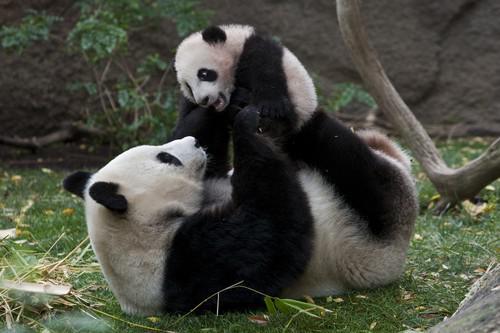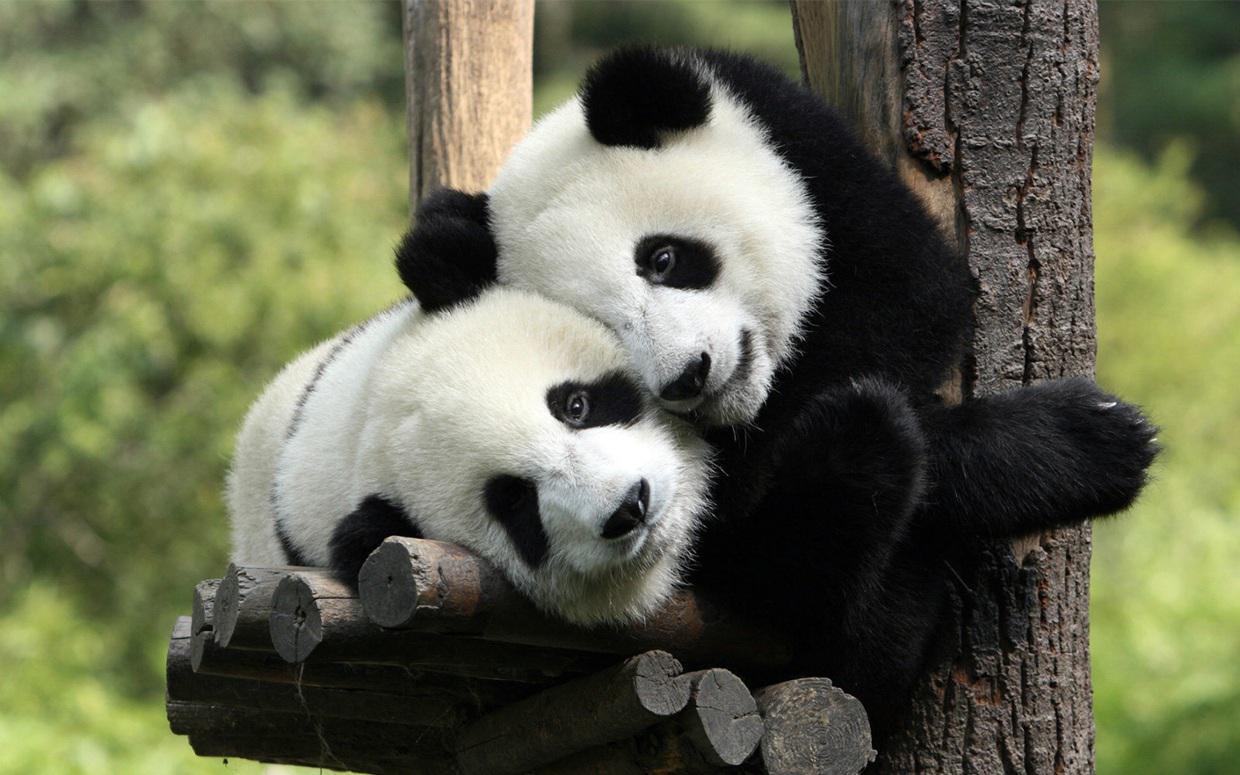The first image is the image on the left, the second image is the image on the right. Assess this claim about the two images: "There are two pandas in the image on the right.". Correct or not? Answer yes or no. Yes. 